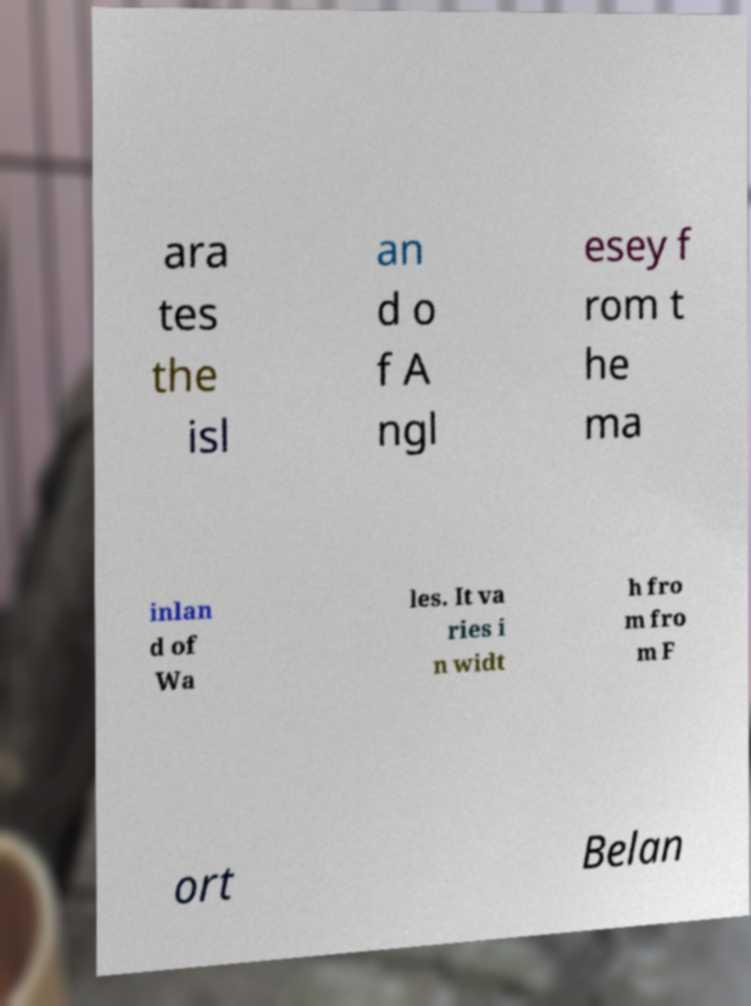Can you read and provide the text displayed in the image?This photo seems to have some interesting text. Can you extract and type it out for me? ara tes the isl an d o f A ngl esey f rom t he ma inlan d of Wa les. It va ries i n widt h fro m fro m F ort Belan 